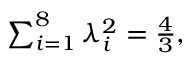<formula> <loc_0><loc_0><loc_500><loc_500>\begin{array} { r } { \sum _ { i = 1 } ^ { 8 } \lambda _ { i } ^ { 2 } = \frac { 4 } { 3 } , } \end{array}</formula> 